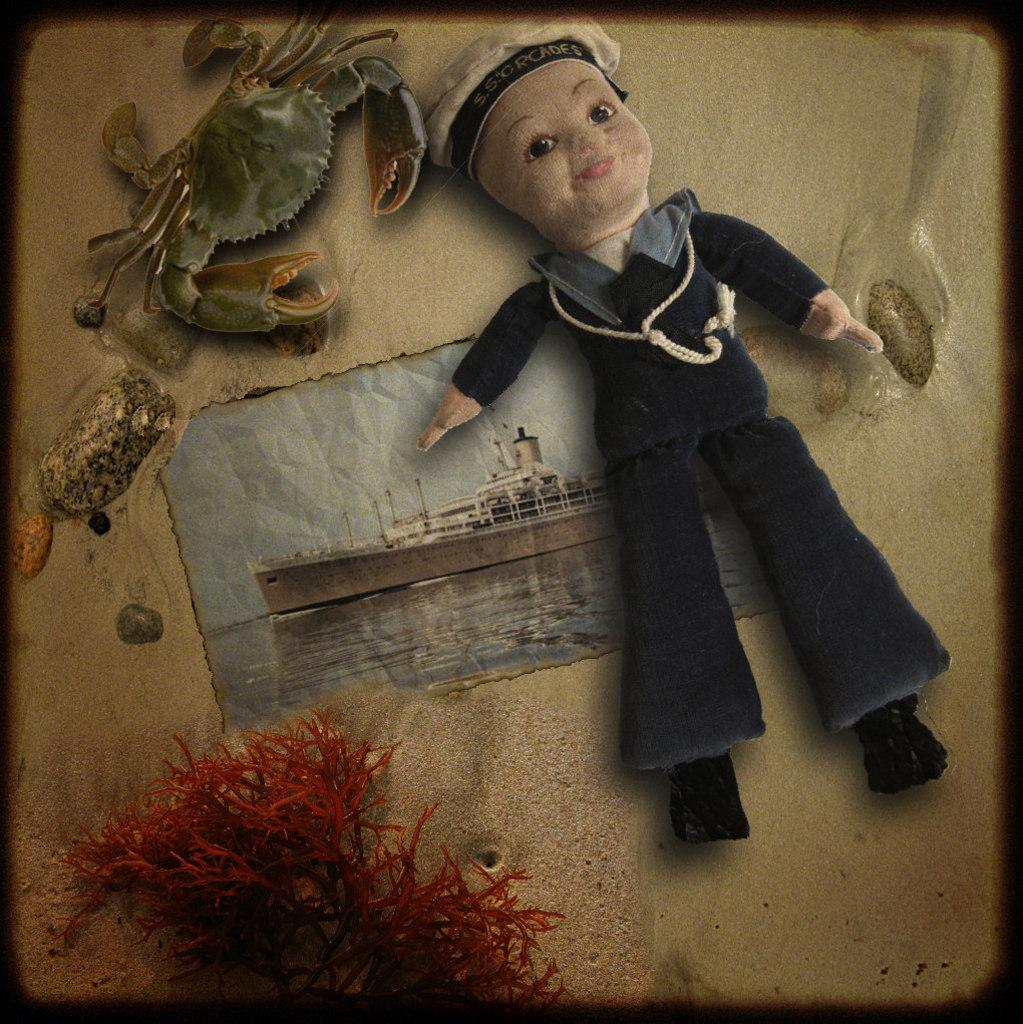What object can be seen in the image that is meant for play or entertainment? There is a toy in the image. What animal is depicted in the image? There is a depiction of a crab in the image. What is shown on the poster in the image? The poster in the image has a ship and water. What type of plant is present at the bottom of the image? There is a red color plant at the bottom of the image. Can you see a pipe being used by the crab in the image? There is no pipe present in the image, nor is the crab using one. Is there a garden visible in the image? There is no garden depicted in the image. 